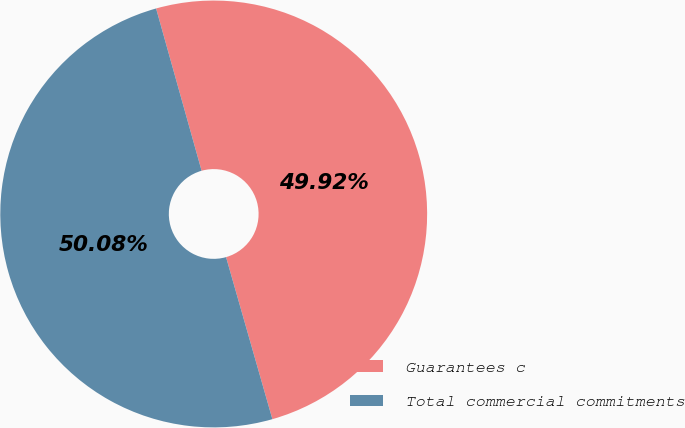Convert chart to OTSL. <chart><loc_0><loc_0><loc_500><loc_500><pie_chart><fcel>Guarantees c<fcel>Total commercial commitments<nl><fcel>49.92%<fcel>50.08%<nl></chart> 